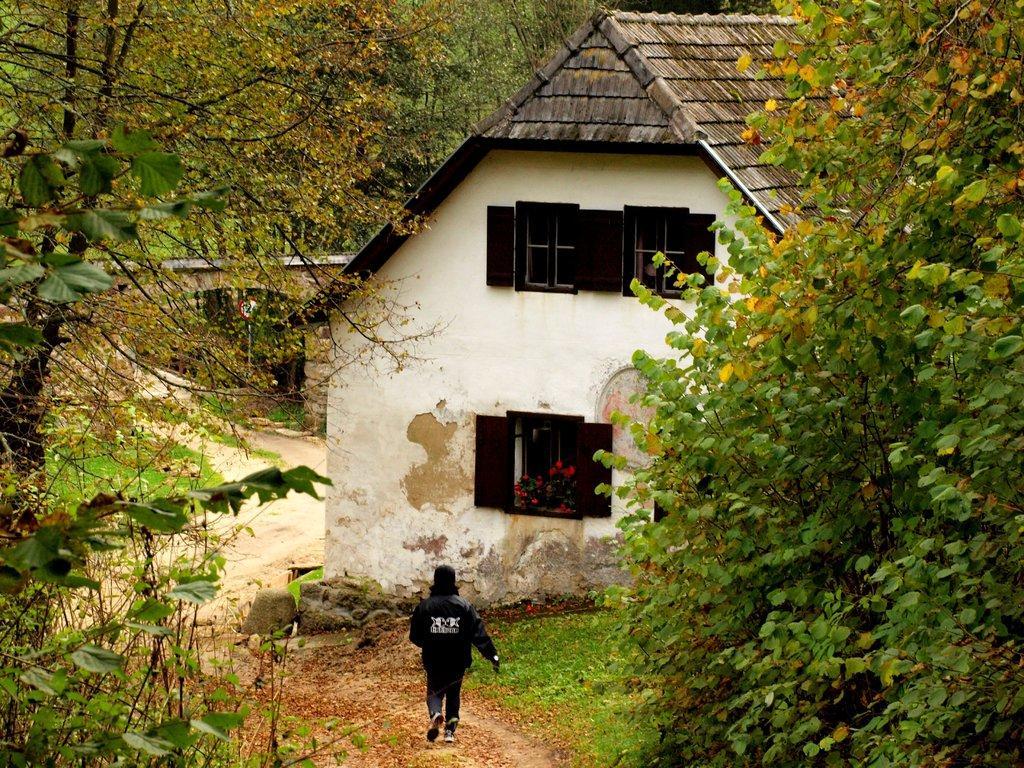Could you give a brief overview of what you see in this image? Here we can see a person. This is grass and there are plants with flowers. Here we can see trees, house, windows, and a board attached to a pole. 